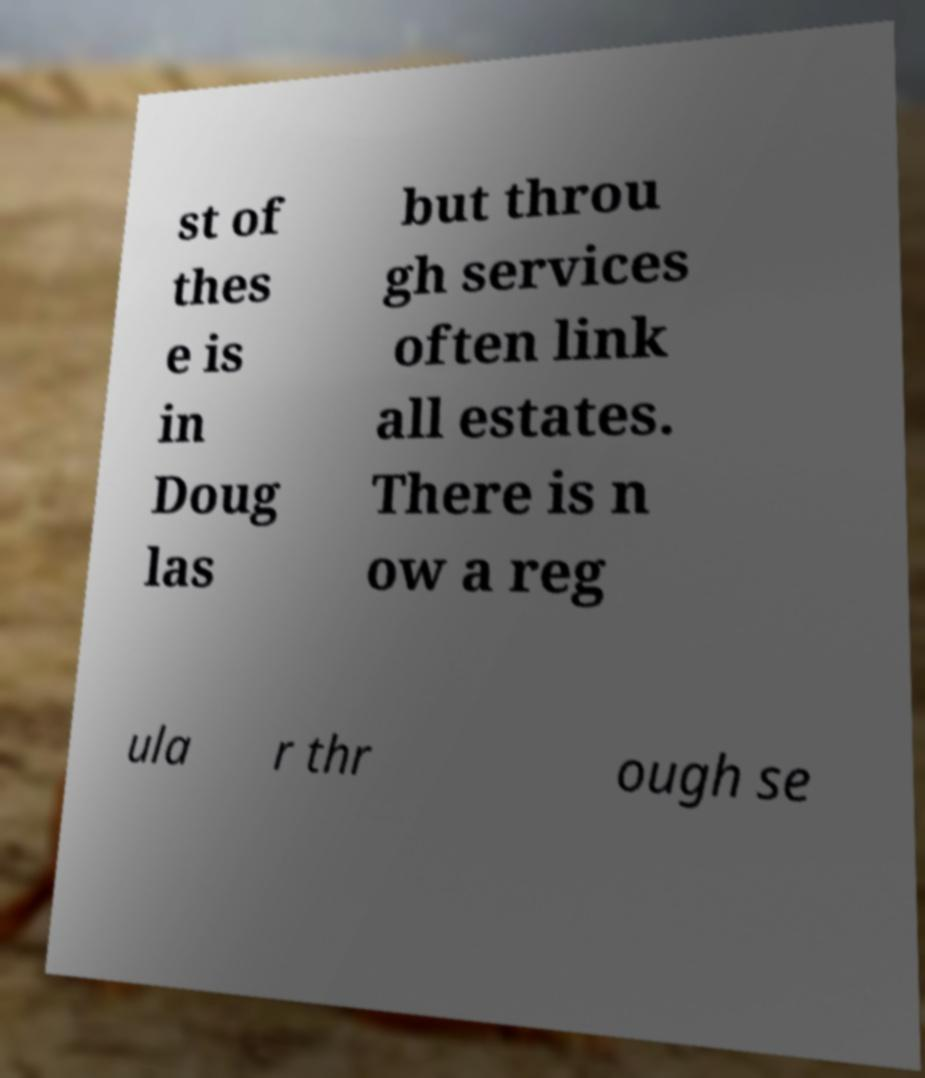Please identify and transcribe the text found in this image. st of thes e is in Doug las but throu gh services often link all estates. There is n ow a reg ula r thr ough se 